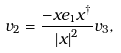<formula> <loc_0><loc_0><loc_500><loc_500>v _ { 2 } = \frac { - x e _ { 1 } x ^ { \dagger } } { \left | x \right | ^ { 2 } } v _ { 3 } ,</formula> 